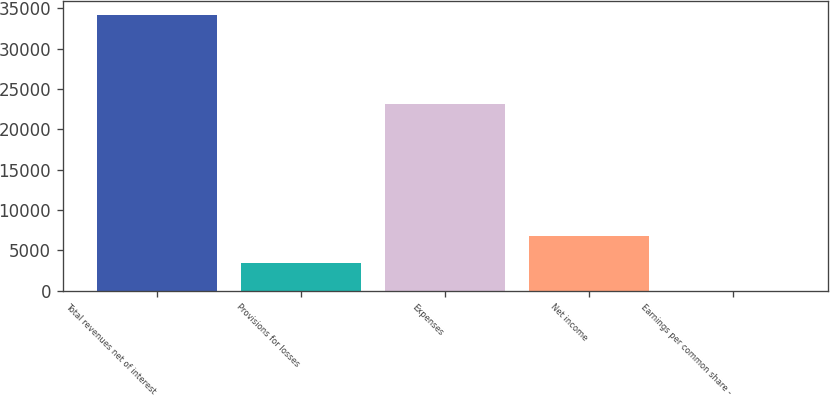Convert chart. <chart><loc_0><loc_0><loc_500><loc_500><bar_chart><fcel>Total revenues net of interest<fcel>Provisions for losses<fcel>Expenses<fcel>Net income<fcel>Earnings per common share -<nl><fcel>34188<fcel>3423.8<fcel>23153<fcel>6842.04<fcel>5.56<nl></chart> 